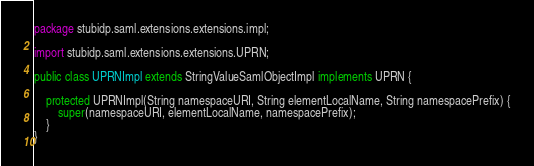Convert code to text. <code><loc_0><loc_0><loc_500><loc_500><_Java_>package stubidp.saml.extensions.extensions.impl;

import stubidp.saml.extensions.extensions.UPRN;

public class UPRNImpl extends StringValueSamlObjectImpl implements UPRN {

    protected UPRNImpl(String namespaceURI, String elementLocalName, String namespacePrefix) {
        super(namespaceURI, elementLocalName, namespacePrefix);
    }
}
</code> 